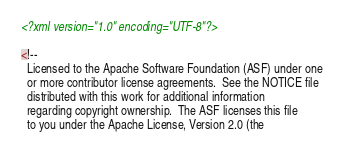Convert code to text. <code><loc_0><loc_0><loc_500><loc_500><_XML_><?xml version="1.0" encoding="UTF-8"?>

<!--
  Licensed to the Apache Software Foundation (ASF) under one
  or more contributor license agreements.  See the NOTICE file
  distributed with this work for additional information
  regarding copyright ownership.  The ASF licenses this file
  to you under the Apache License, Version 2.0 (the</code> 